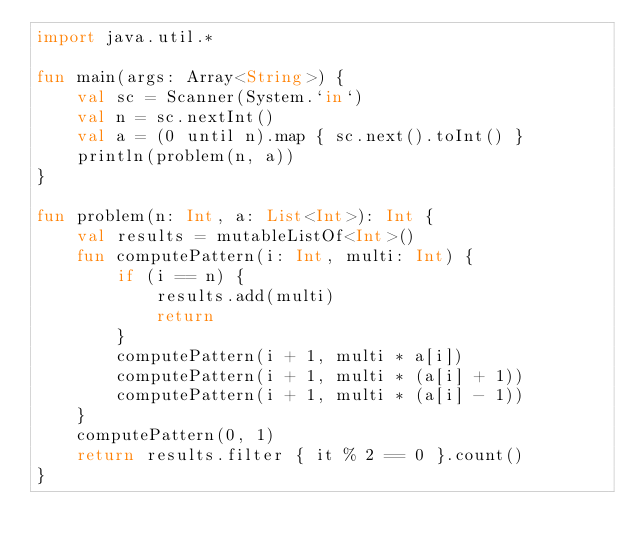Convert code to text. <code><loc_0><loc_0><loc_500><loc_500><_Kotlin_>import java.util.*

fun main(args: Array<String>) {
    val sc = Scanner(System.`in`)
    val n = sc.nextInt()
    val a = (0 until n).map { sc.next().toInt() }
    println(problem(n, a))
}

fun problem(n: Int, a: List<Int>): Int {
    val results = mutableListOf<Int>()
    fun computePattern(i: Int, multi: Int) {
        if (i == n) {
            results.add(multi)
            return
        }
        computePattern(i + 1, multi * a[i])
        computePattern(i + 1, multi * (a[i] + 1))
        computePattern(i + 1, multi * (a[i] - 1))
    }
    computePattern(0, 1)
    return results.filter { it % 2 == 0 }.count()
}</code> 